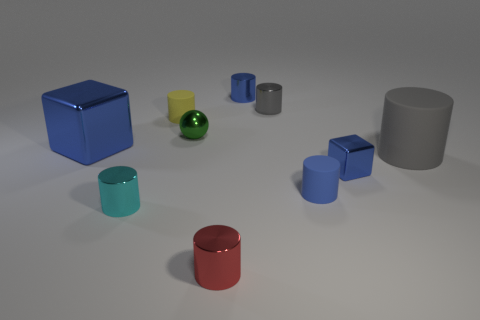What shape is the rubber object that is the same color as the large metallic block?
Provide a succinct answer. Cylinder. There is a tiny gray thing; are there any cylinders in front of it?
Make the answer very short. Yes. Is the shape of the small gray shiny thing the same as the large blue shiny thing?
Provide a succinct answer. No. What size is the blue cube on the left side of the matte cylinder on the left side of the small shiny cylinder in front of the small cyan cylinder?
Offer a terse response. Large. What material is the large cylinder?
Offer a very short reply. Rubber. The thing that is the same color as the big cylinder is what size?
Ensure brevity in your answer.  Small. Does the red thing have the same shape as the blue shiny thing that is in front of the big metal thing?
Ensure brevity in your answer.  No. The gray object that is on the right side of the small blue cylinder in front of the small rubber cylinder behind the large rubber object is made of what material?
Ensure brevity in your answer.  Rubber. What number of tiny red cylinders are there?
Your answer should be very brief. 1. What number of gray things are either small rubber balls or metal cylinders?
Keep it short and to the point. 1. 